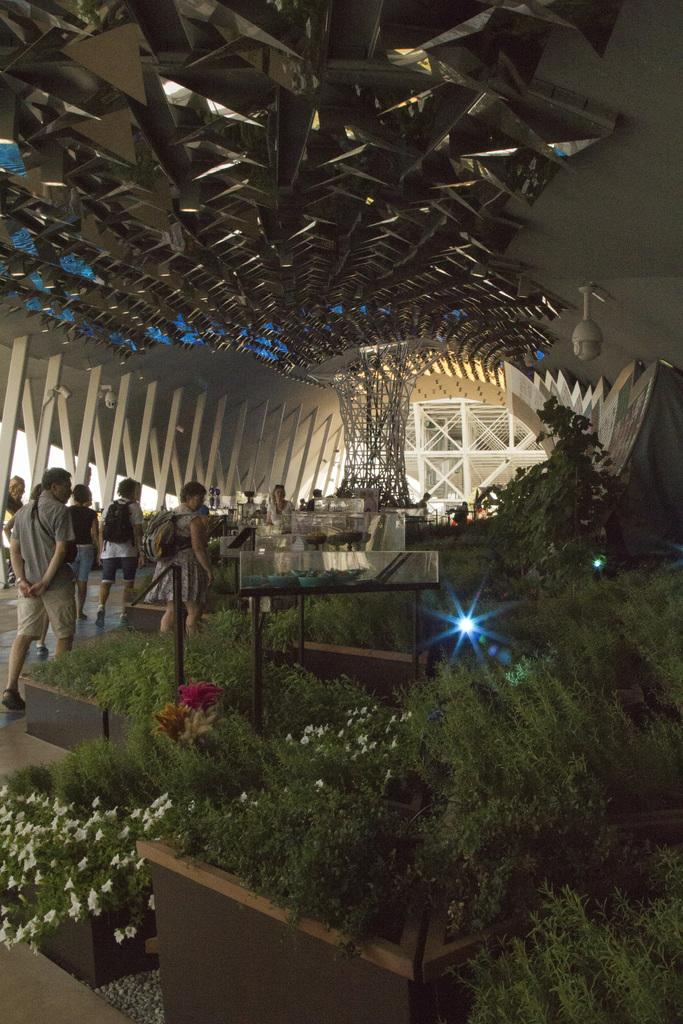What can be seen on the left side of the image? There are many people on the left side of the image. What is located in the middle of the image? There are plants, lights, people, architecture, a CCTV camera, and a wall in the middle of the image. How many beds can be seen in the image? There are no beds present in the image. What type of seed is being planted in the middle of the image? There is no seed being planted in the image; it features plants, lights, people, architecture, a CCTV camera, and a wall. 